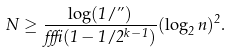<formula> <loc_0><loc_0><loc_500><loc_500>N \geq \frac { \log ( 1 / \varepsilon ) } { \alpha \beta ( 1 - 1 / 2 ^ { k - 1 } ) } ( \log _ { 2 } n ) ^ { 2 } .</formula> 